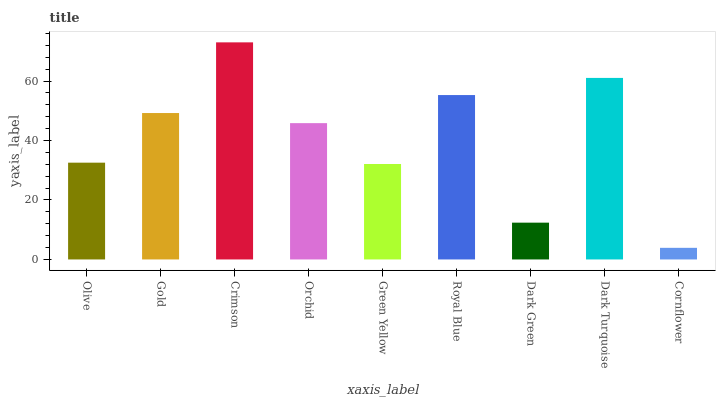Is Gold the minimum?
Answer yes or no. No. Is Gold the maximum?
Answer yes or no. No. Is Gold greater than Olive?
Answer yes or no. Yes. Is Olive less than Gold?
Answer yes or no. Yes. Is Olive greater than Gold?
Answer yes or no. No. Is Gold less than Olive?
Answer yes or no. No. Is Orchid the high median?
Answer yes or no. Yes. Is Orchid the low median?
Answer yes or no. Yes. Is Olive the high median?
Answer yes or no. No. Is Green Yellow the low median?
Answer yes or no. No. 